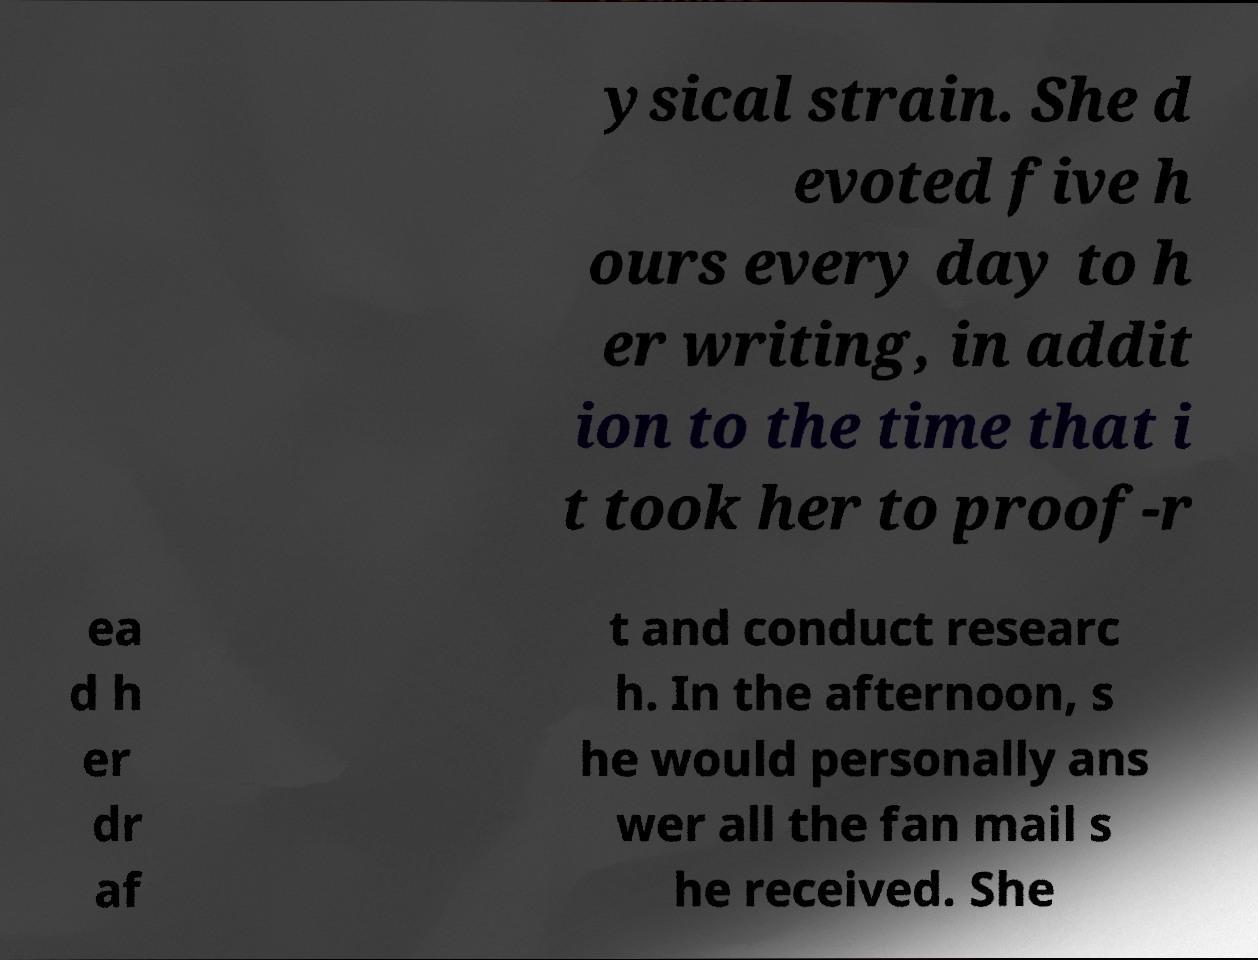What messages or text are displayed in this image? I need them in a readable, typed format. ysical strain. She d evoted five h ours every day to h er writing, in addit ion to the time that i t took her to proof-r ea d h er dr af t and conduct researc h. In the afternoon, s he would personally ans wer all the fan mail s he received. She 